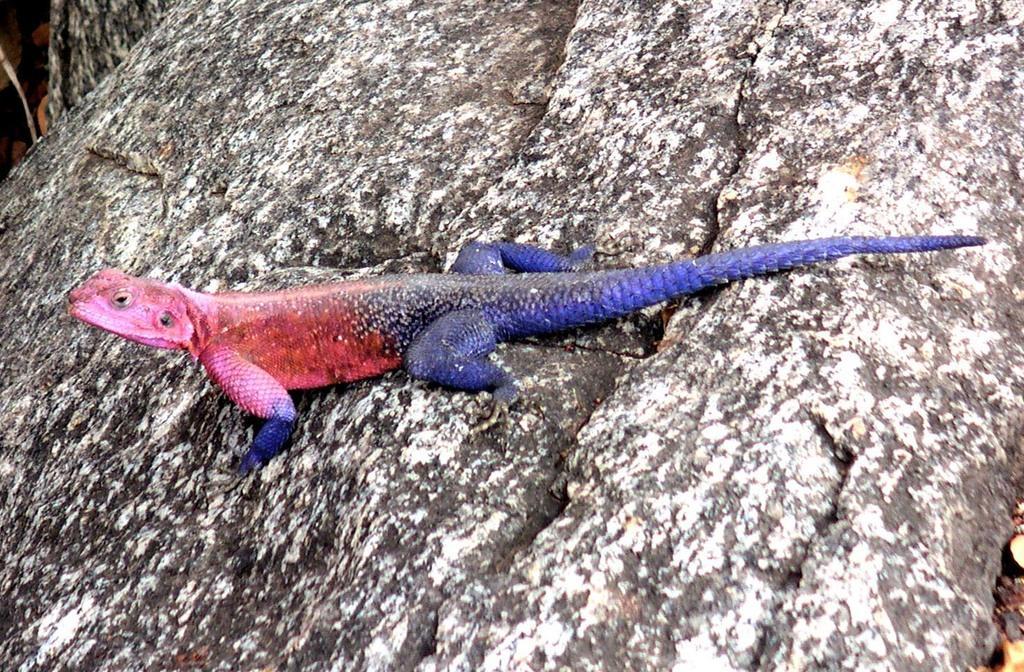Can you describe this image briefly? In this image we can see one colorful reptile on the rock, left and right side of the image there are some objects on the ground. 